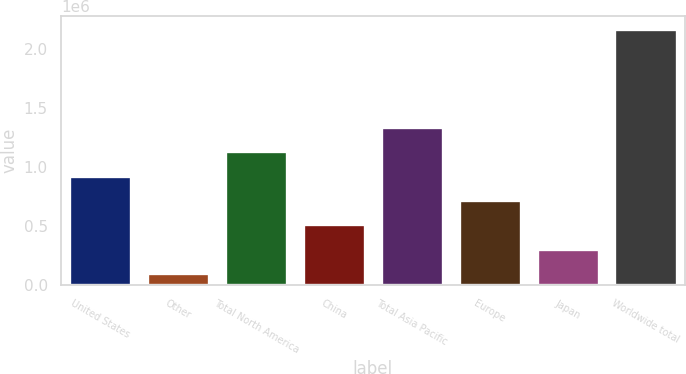Convert chart. <chart><loc_0><loc_0><loc_500><loc_500><bar_chart><fcel>United States<fcel>Other<fcel>Total North America<fcel>China<fcel>Total Asia Pacific<fcel>Europe<fcel>Japan<fcel>Worldwide total<nl><fcel>925811<fcel>97251<fcel>1.13295e+06<fcel>511531<fcel>1.34009e+06<fcel>718671<fcel>304391<fcel>2.16865e+06<nl></chart> 